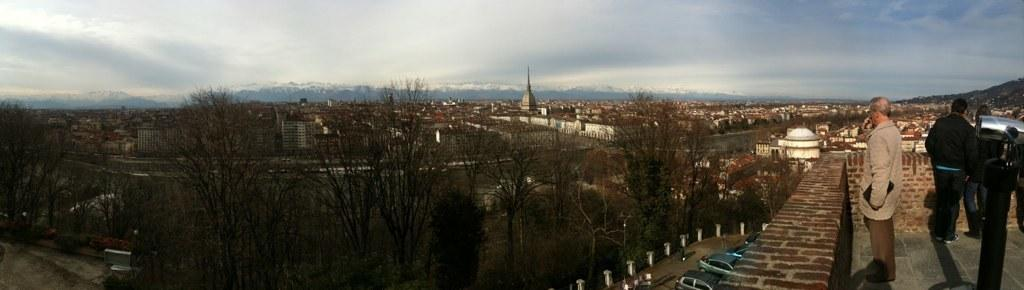What type of natural elements can be seen in the image? There are trees and mountains in the image. What type of man-made structures are visible in the image? There are buildings in the image. What type of vehicles can be seen in the image? There are cars in the image. What are the people in the image doing? The people are standing on the floor in the image. What is visible in the background of the image? The sky is visible in the background of the image, and there are clouds present in the sky. Can you tell me how many ears of corn are visible in the image? There is no corn present in the image. What type of sock is being worn by the person standing on the trail in the image? There is no trail or person wearing a sock in the image. 